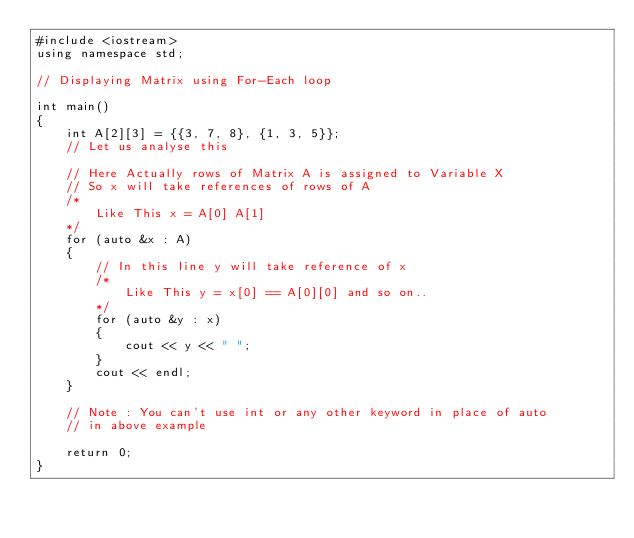Convert code to text. <code><loc_0><loc_0><loc_500><loc_500><_C++_>#include <iostream>
using namespace std;

// Displaying Matrix using For-Each loop

int main()
{
    int A[2][3] = {{3, 7, 8}, {1, 3, 5}};
    // Let us analyse this

    // Here Actually rows of Matrix A is assigned to Variable X
    // So x will take references of rows of A
    /*
        Like This x = A[0] A[1] 
    */
    for (auto &x : A)
    {
        // In this line y will take reference of x
        /*
            Like This y = x[0] == A[0][0] and so on..
        */
        for (auto &y : x)
        {
            cout << y << " ";
        }
        cout << endl;
    }

    // Note : You can't use int or any other keyword in place of auto
    // in above example

    return 0;
}
</code> 